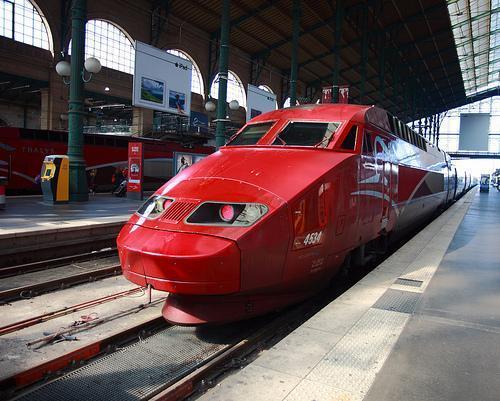How many trains are there?
Give a very brief answer. 1. 